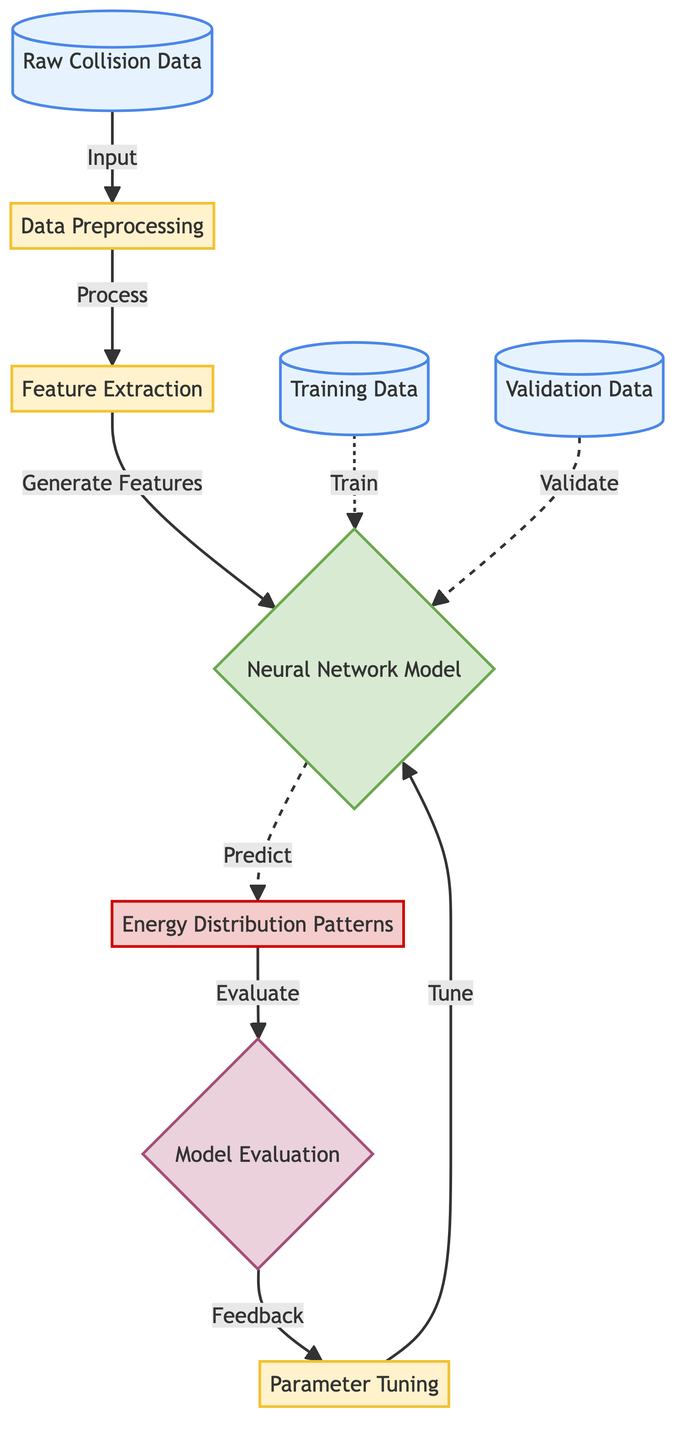What is the first step in the diagram? The diagram shows that the first step involves "Raw Collision Data," which is the starting point before any processing occurs.
Answer: Raw Collision Data How many nodes are there in total? By counting the nodes in the diagram, there are a total of nine nodes that represent various steps in the process.
Answer: Nine What type of model is used in the diagram? The diagram explicitly describes the model as a "Neural Network Model," which is central to the predictions made.
Answer: Neural Network Model What do the training and validation data connect to? Both the training data and validation data connect to the neural network model, indicating that they are used for training and validation purposes in the analysis process.
Answer: Neural Network Model What is the output of the model? According to the diagram, the output produced by the neural network model is "Energy Distribution Patterns," which represents the predictions made.
Answer: Energy Distribution Patterns What is done after evaluating the model? After the model evaluation, the diagram indicates feedback is provided, which is then used for parameter tuning, allowing further refinements of the model.
Answer: Parameter Tuning Explain the relationship between data preprocessing and feature extraction. Data preprocessing is the step that feeds into feature extraction. It prepares the raw collision data so that useful features can be generated for the neural network model.
Answer: Feature Extraction How does parameter tuning fit into the overall process? Parameter tuning occurs after model evaluation, using the feedback from evaluation to adjust the neural network model, ensuring better performance in future predictions.
Answer: Tuning What node follows the "Data Preprocessing" step? The node that follows the "Data Preprocessing" step is "Feature Extraction," indicating that this step directly depends on the processed data.
Answer: Feature Extraction 